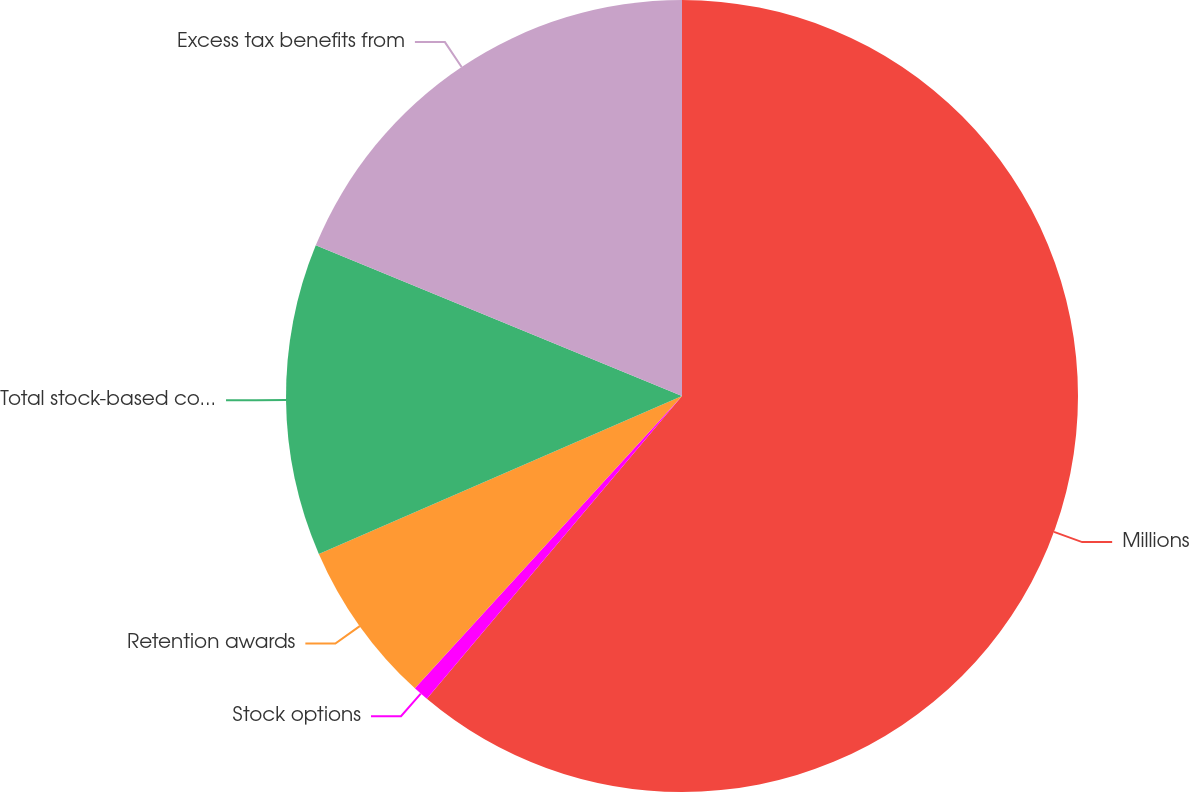Convert chart to OTSL. <chart><loc_0><loc_0><loc_500><loc_500><pie_chart><fcel>Millions<fcel>Stock options<fcel>Retention awards<fcel>Total stock-based compensation<fcel>Excess tax benefits from<nl><fcel>61.15%<fcel>0.64%<fcel>6.69%<fcel>12.74%<fcel>18.79%<nl></chart> 